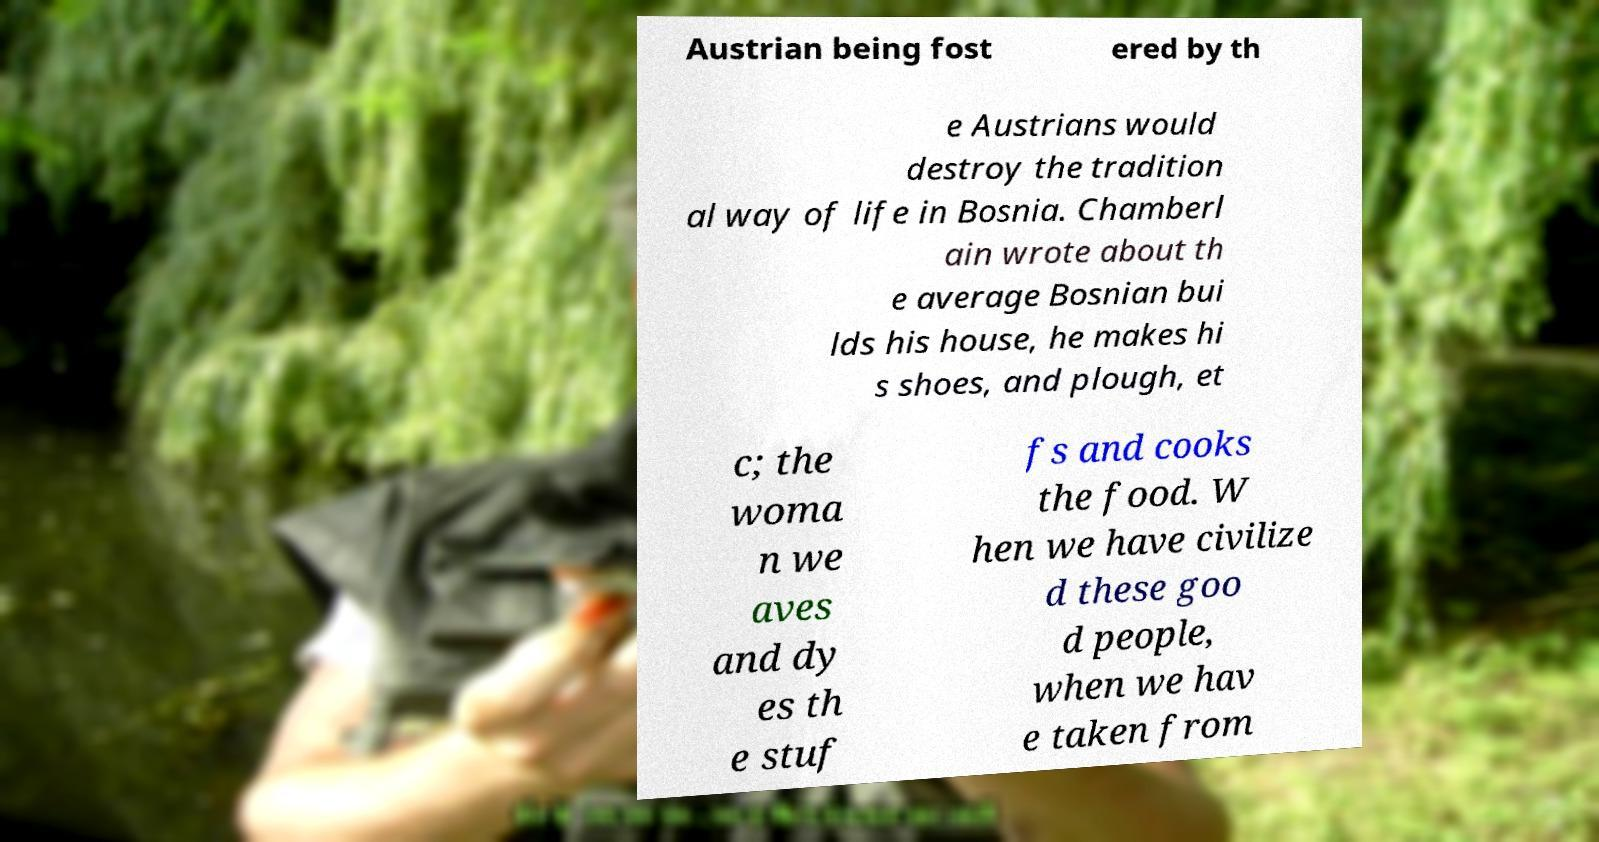What messages or text are displayed in this image? I need them in a readable, typed format. Austrian being fost ered by th e Austrians would destroy the tradition al way of life in Bosnia. Chamberl ain wrote about th e average Bosnian bui lds his house, he makes hi s shoes, and plough, et c; the woma n we aves and dy es th e stuf fs and cooks the food. W hen we have civilize d these goo d people, when we hav e taken from 